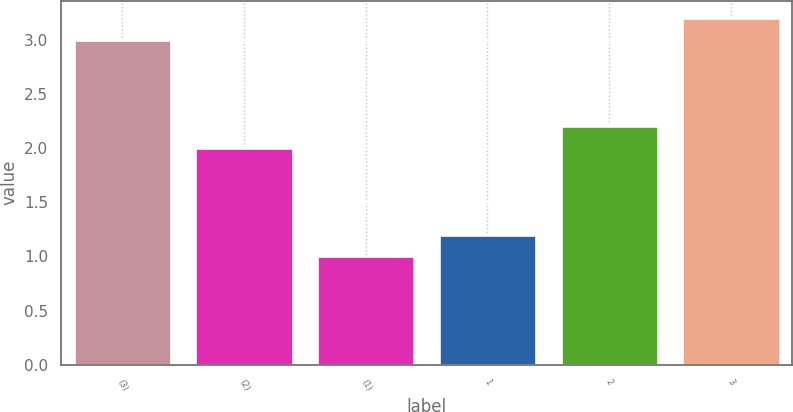Convert chart to OTSL. <chart><loc_0><loc_0><loc_500><loc_500><bar_chart><fcel>(3)<fcel>(2)<fcel>(1)<fcel>1<fcel>2<fcel>3<nl><fcel>3<fcel>2<fcel>1<fcel>1.2<fcel>2.2<fcel>3.2<nl></chart> 